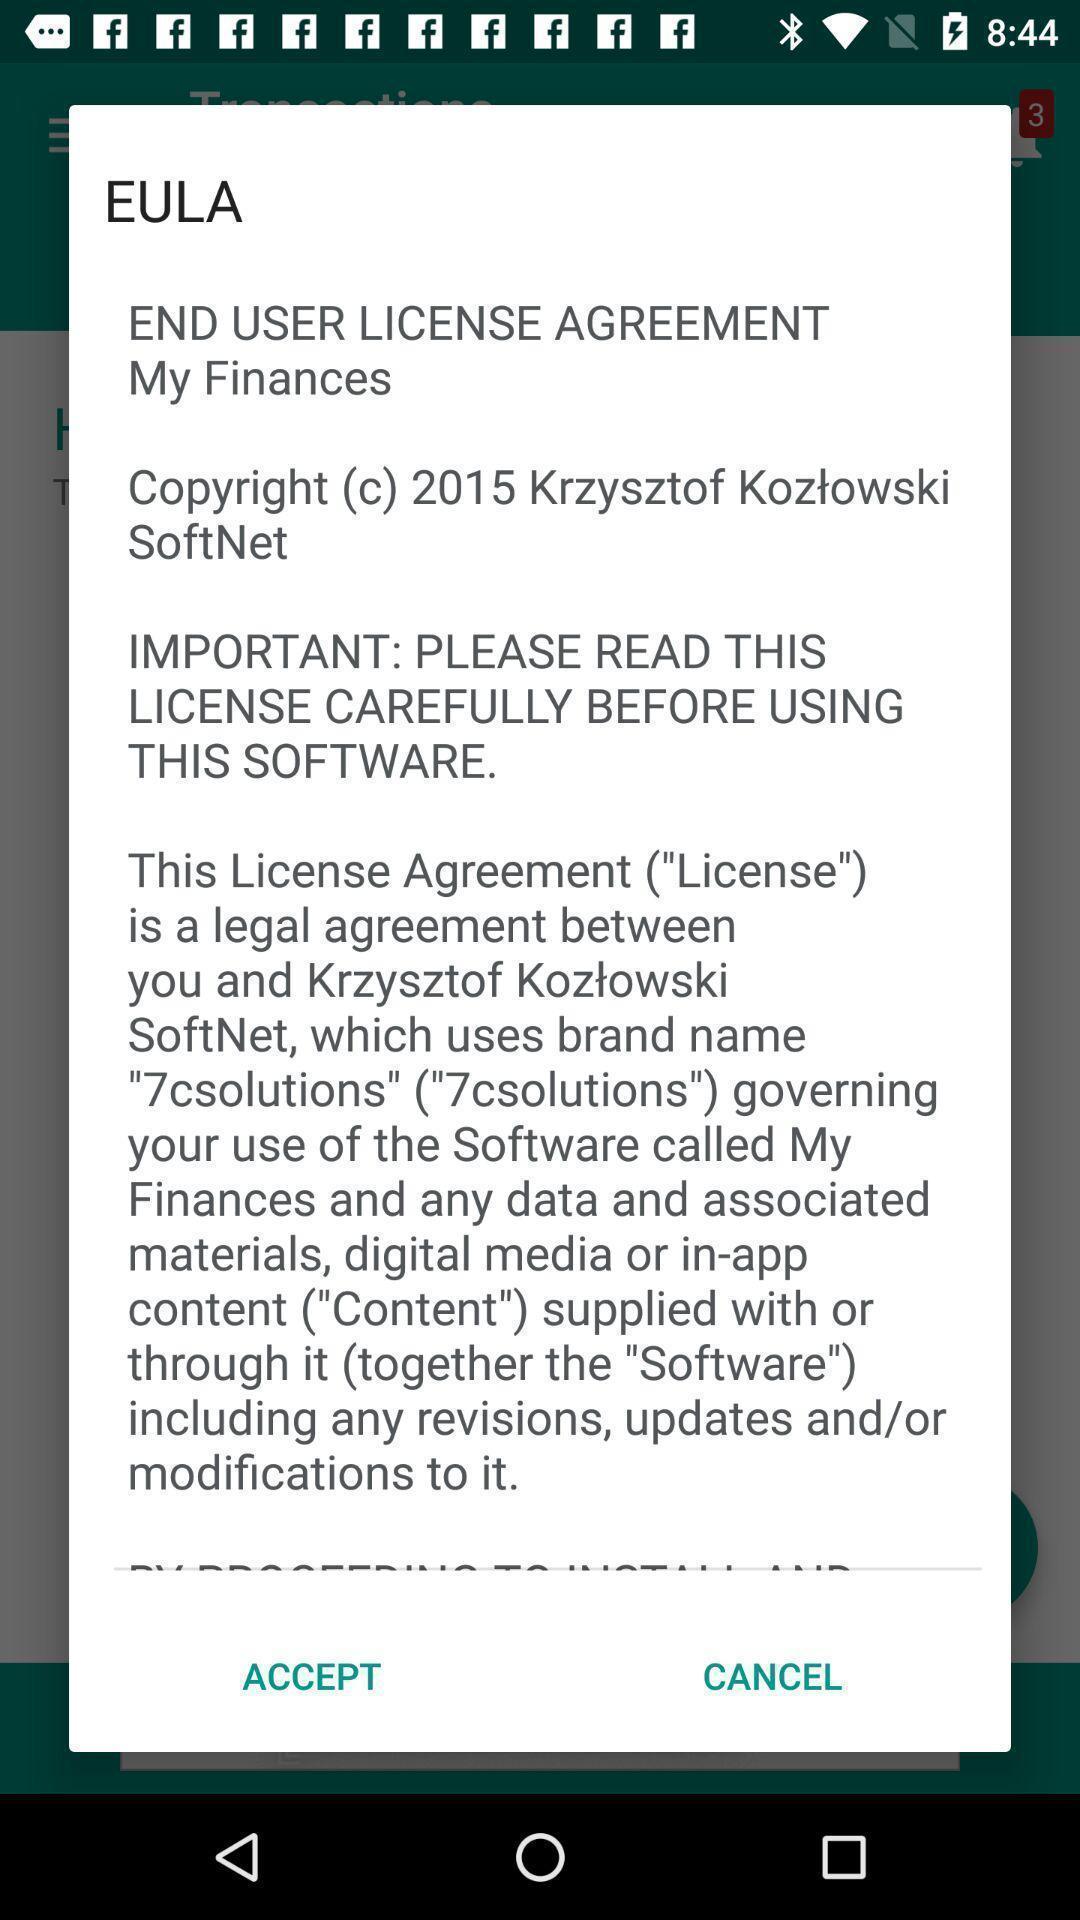Describe the visual elements of this screenshot. Popup displaying license information about home budget management application. 